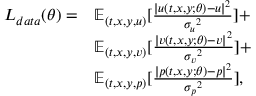Convert formula to latex. <formula><loc_0><loc_0><loc_500><loc_500>\begin{array} { r l } { L _ { d a t a } ( \theta ) = } & { \mathbb { E } _ { ( t , x , y , u ) } [ \frac { | { u } ( t , x , y ; \theta ) - { u } | ^ { 2 } } { { \sigma _ { u } } ^ { 2 } } ] + } \\ & { \mathbb { E } _ { ( t , x , y , v ) } [ \frac { | { v } ( t , x , y ; \theta ) - { v } | ^ { 2 } } { { \sigma _ { v } } ^ { 2 } } ] + } \\ & { \mathbb { E } _ { ( t , x , y , p ) } [ \frac { | { p } ( t , x , y ; \theta ) - { p } | ^ { 2 } } { { \sigma _ { p } } ^ { 2 } } ] , } \end{array}</formula> 